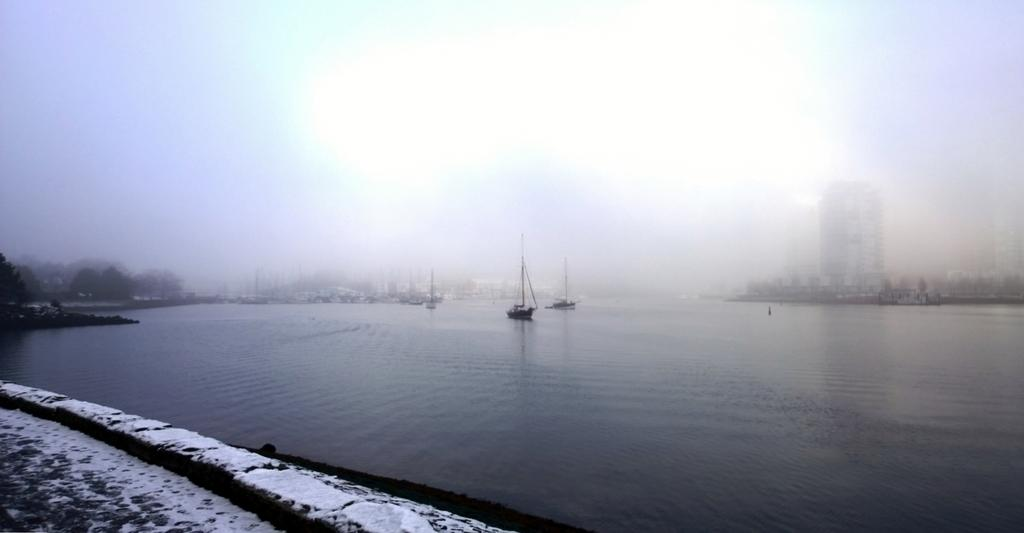What is positioned above the water in the image? There are boats above the water in the image. What can be seen at the bottom of the image? There is a walkway at the bottom of the image, and snow is visible there. What is visible in the background of the image? There are trees and at least one building in the background of the image, and fog is present as well. What size of fireman can be seen in the image? There is no fireman present in the image. What causes the boats to burst in the image? The boats do not burst in the image; they are stationary above the water. 